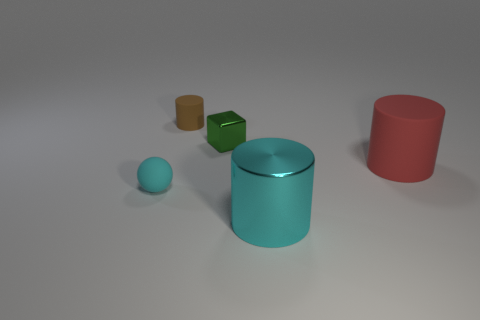What is the brown cylinder made of?
Offer a terse response. Rubber. What number of other things are there of the same material as the large red object
Give a very brief answer. 2. How many cyan rubber things are there?
Provide a succinct answer. 1. There is a brown thing that is the same shape as the big red thing; what is it made of?
Provide a short and direct response. Rubber. Do the cyan object in front of the small matte ball and the red cylinder have the same material?
Provide a succinct answer. No. Are there more matte cylinders that are on the left side of the red rubber cylinder than tiny green metallic things behind the small brown cylinder?
Your answer should be compact. Yes. What size is the red cylinder?
Your response must be concise. Large. There is a big thing that is made of the same material as the cyan ball; what is its shape?
Make the answer very short. Cylinder. Do the rubber thing that is to the right of the large cyan cylinder and the tiny cyan object have the same shape?
Offer a very short reply. No. What number of objects are metallic cubes or large blue matte cubes?
Offer a very short reply. 1. 